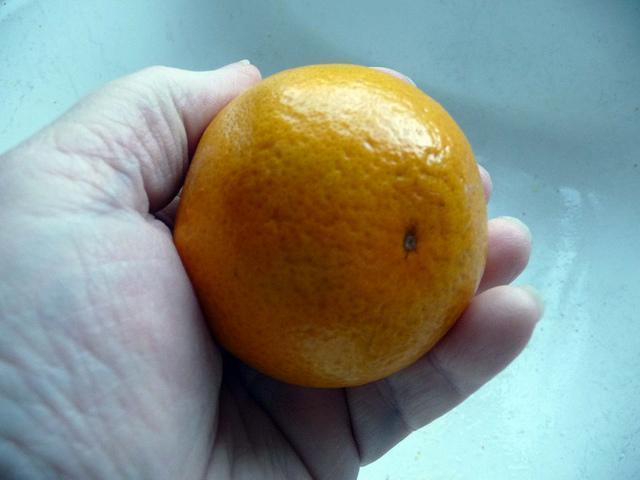How many fruit are cut?
Give a very brief answer. 0. How many candles on the cake are not lit?
Give a very brief answer. 0. 